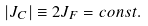Convert formula to latex. <formula><loc_0><loc_0><loc_500><loc_500>| J _ { C } | \equiv 2 J _ { F } = c o n s t .</formula> 